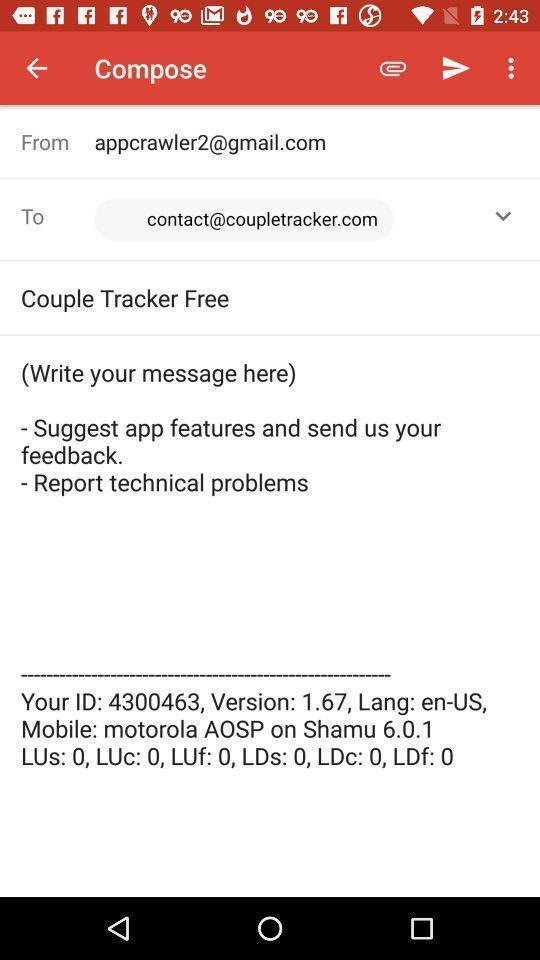What is the overall content of this screenshot? Screen displaying the compose page of a mail app. 